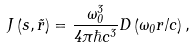<formula> <loc_0><loc_0><loc_500><loc_500>J \left ( s , \vec { r } \right ) = \frac { \omega _ { 0 } ^ { 3 } } { 4 \pi \hbar { c } ^ { 3 } } D \left ( \omega _ { 0 } r / c \right ) ,</formula> 